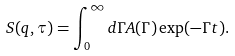<formula> <loc_0><loc_0><loc_500><loc_500>S ( q , \tau ) = \int _ { 0 } ^ { \infty } d \Gamma A ( \Gamma ) \exp ( - \Gamma t ) .</formula> 